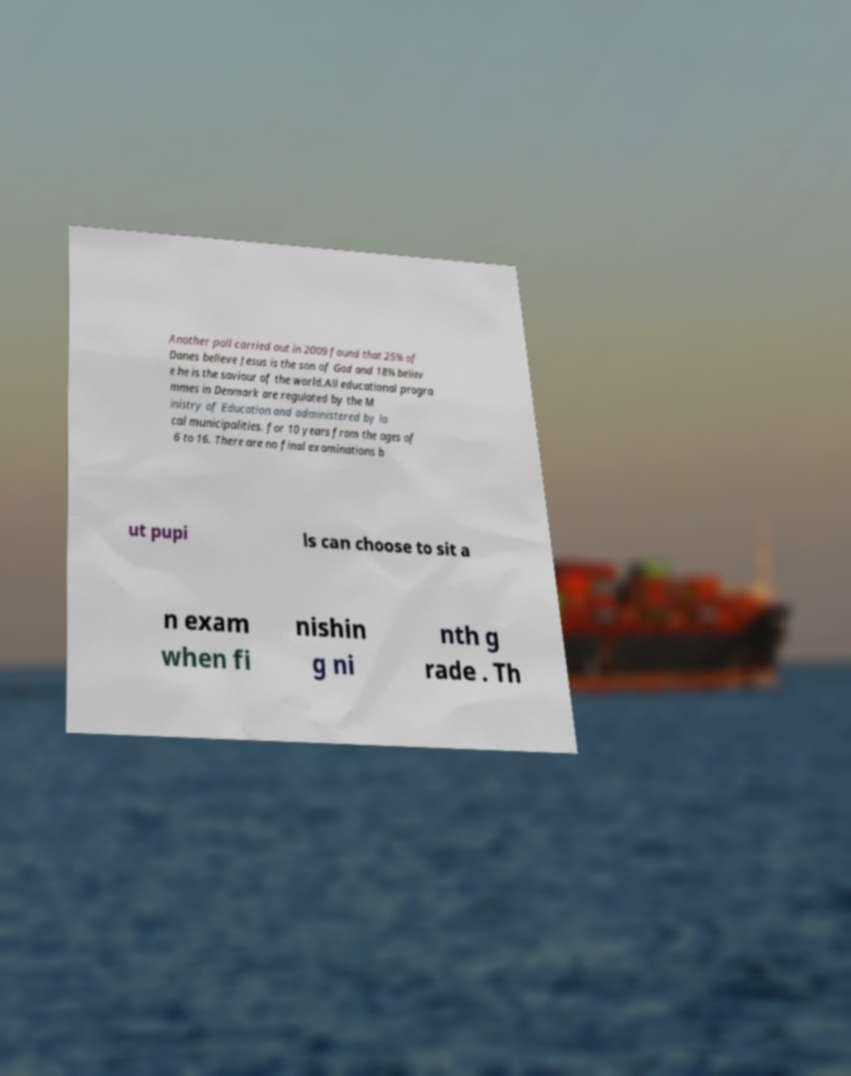For documentation purposes, I need the text within this image transcribed. Could you provide that? Another poll carried out in 2009 found that 25% of Danes believe Jesus is the son of God and 18% believ e he is the saviour of the world.All educational progra mmes in Denmark are regulated by the M inistry of Education and administered by lo cal municipalities. for 10 years from the ages of 6 to 16. There are no final examinations b ut pupi ls can choose to sit a n exam when fi nishin g ni nth g rade . Th 